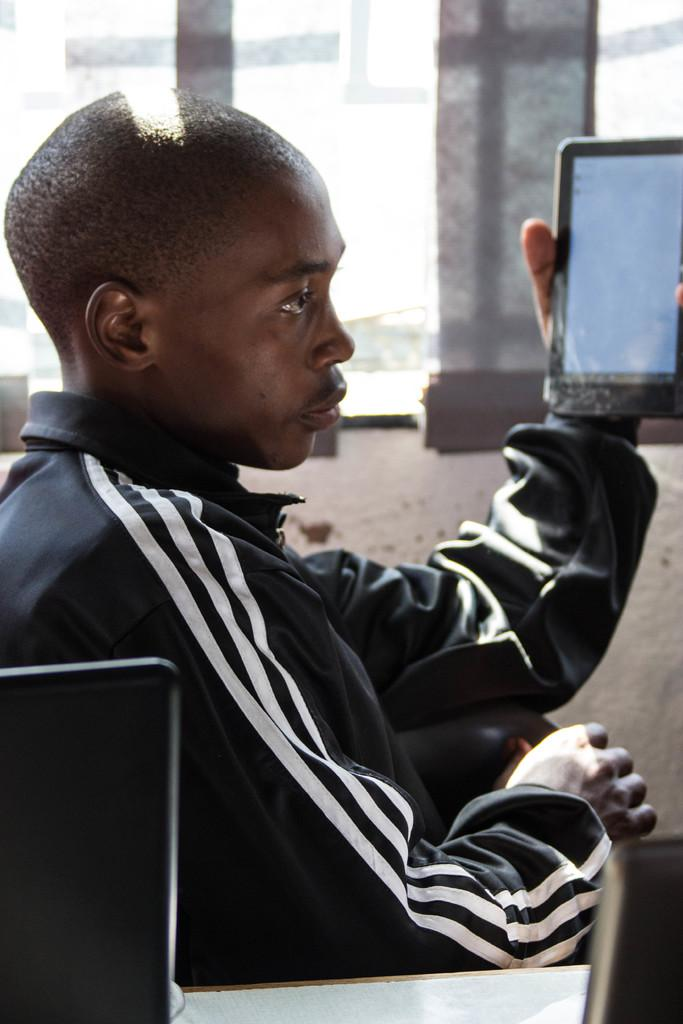Who or what is the main subject in the image? There is a person in the image. What is the person doing in the image? The person is sitting on a chair and holding a mobile phone. Where is the person looking in the image? The person is looking at somewhere. What type of sponge is the person using to act in the image? There is no sponge or act present in the image; the person is simply sitting on a chair and holding a mobile phone. 